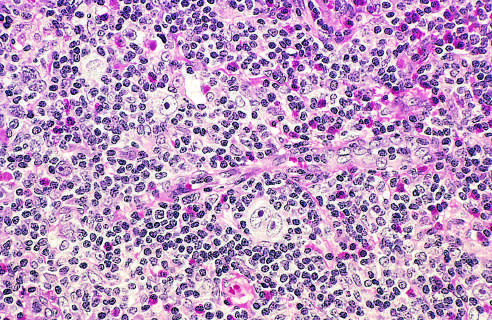what is surrounded by eosinophils, lymphocytes, and histiocytes?
Answer the question using a single word or phrase. A diagnostic 